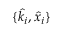<formula> <loc_0><loc_0><loc_500><loc_500>\{ \hat { k _ { i } } , \hat { x } _ { i } \}</formula> 